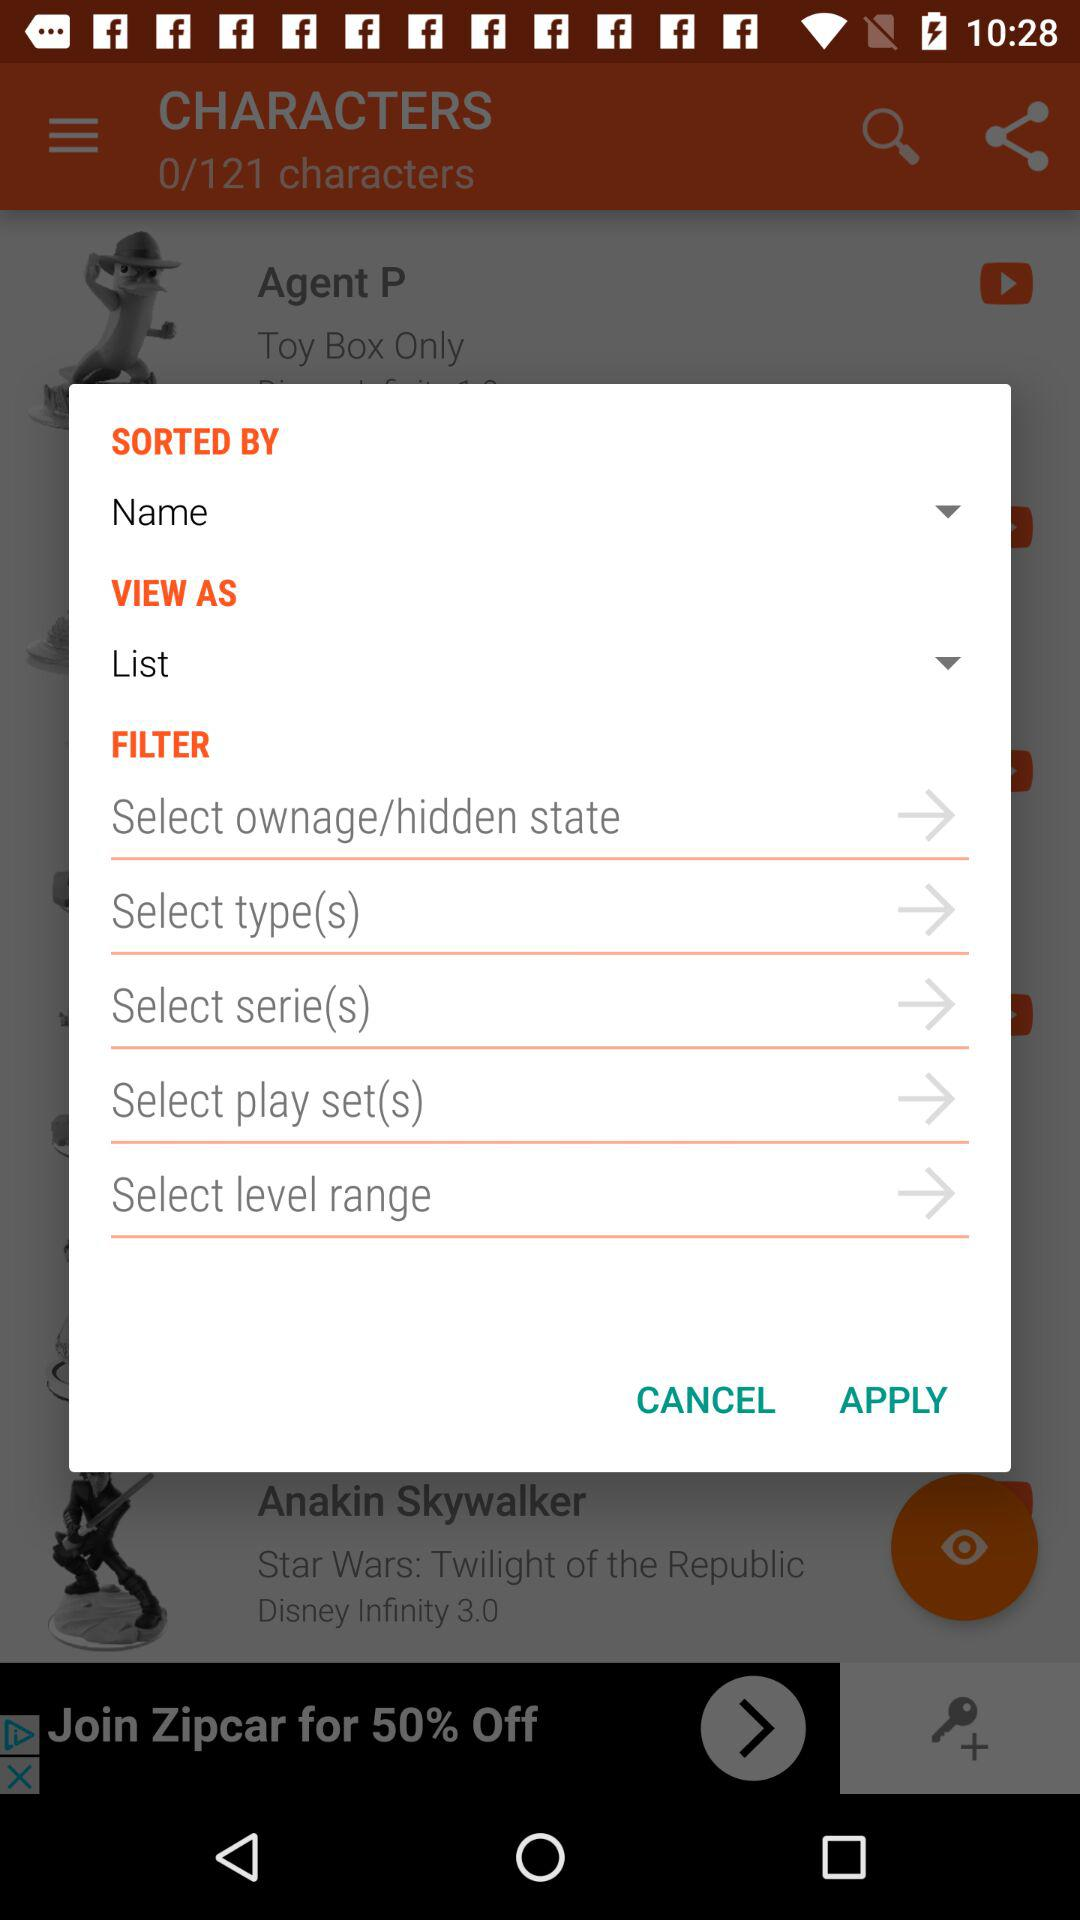How many characters are there? There are 121 characters. 